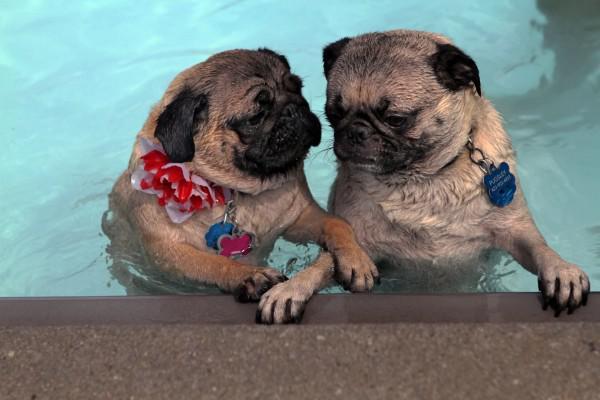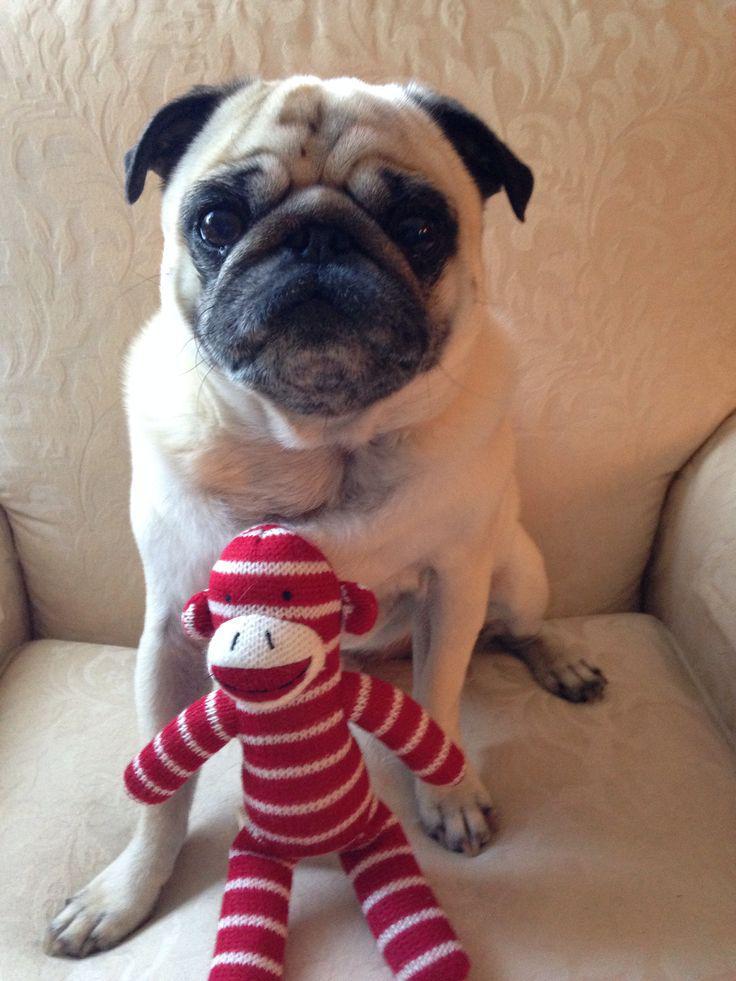The first image is the image on the left, the second image is the image on the right. Examine the images to the left and right. Is the description "There are three dogs." accurate? Answer yes or no. Yes. 